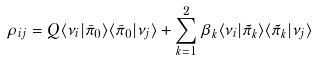Convert formula to latex. <formula><loc_0><loc_0><loc_500><loc_500>\rho _ { i j } = Q \langle \nu _ { i } | \bar { \pi } _ { 0 } \rangle \langle \bar { \pi } _ { 0 } | \nu _ { j } \rangle + \sum _ { k = 1 } ^ { 2 } \beta _ { k } \langle \nu _ { i } | \tilde { \pi } _ { k } \rangle \langle \tilde { \pi } _ { k } | \nu _ { j } \rangle</formula> 